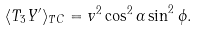Convert formula to latex. <formula><loc_0><loc_0><loc_500><loc_500>\langle T _ { 3 } Y ^ { \prime } \rangle _ { T C } = v ^ { 2 } \cos ^ { 2 } \alpha \sin ^ { 2 } \phi .</formula> 